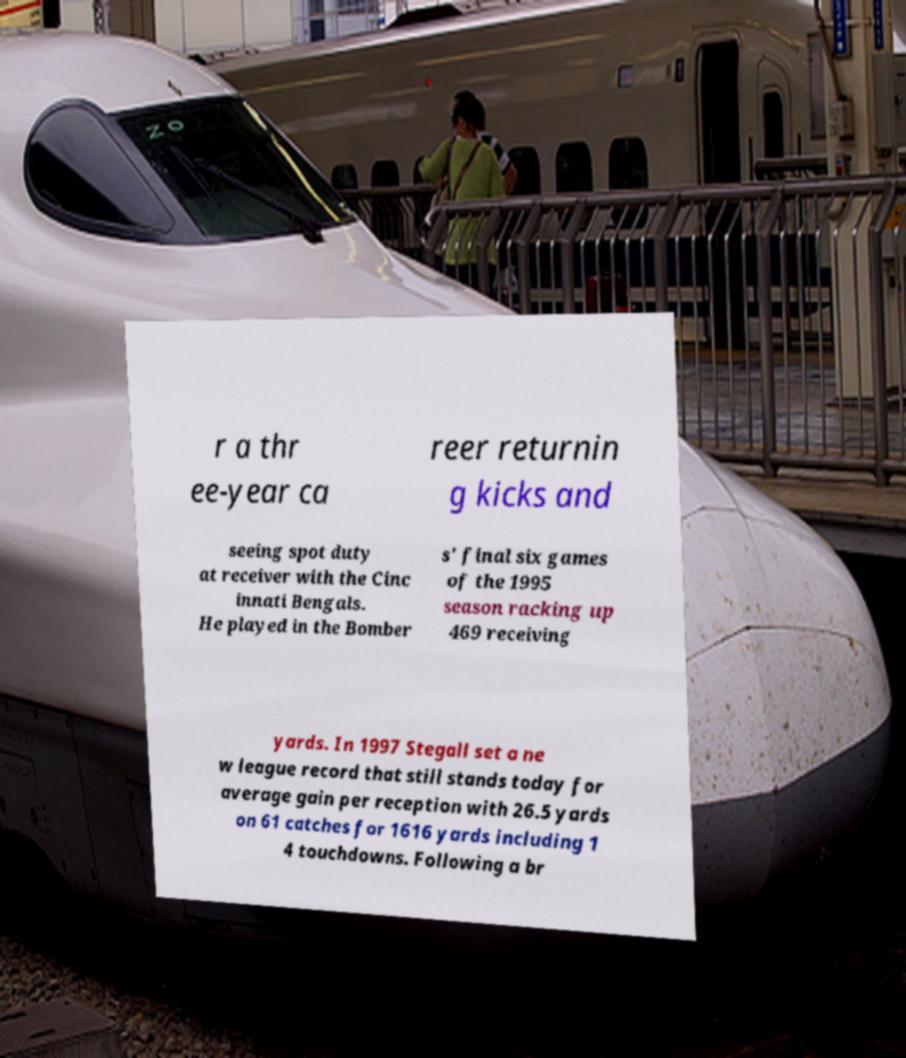Could you assist in decoding the text presented in this image and type it out clearly? r a thr ee-year ca reer returnin g kicks and seeing spot duty at receiver with the Cinc innati Bengals. He played in the Bomber s' final six games of the 1995 season racking up 469 receiving yards. In 1997 Stegall set a ne w league record that still stands today for average gain per reception with 26.5 yards on 61 catches for 1616 yards including 1 4 touchdowns. Following a br 